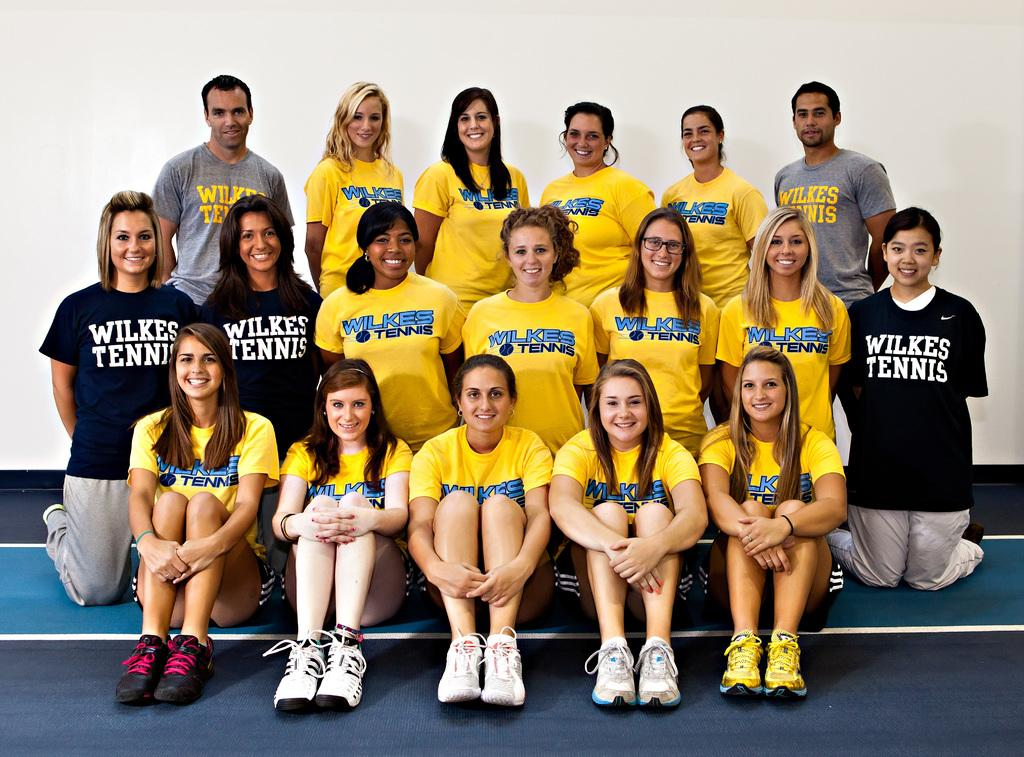<image>
Describe the image concisely. A team that is representing Wilke's Tennis comprised of boys and girls. 